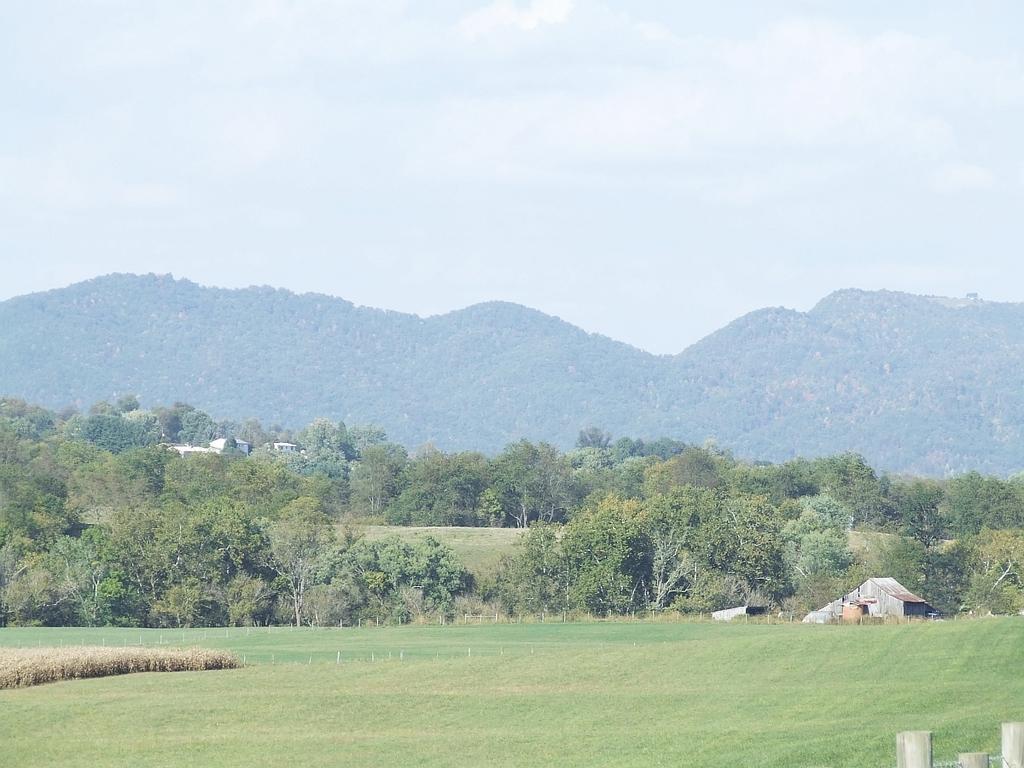Describe this image in one or two sentences. In this picture the ground is greenery and there are trees and mountains in the background and the sky is cloudy. 